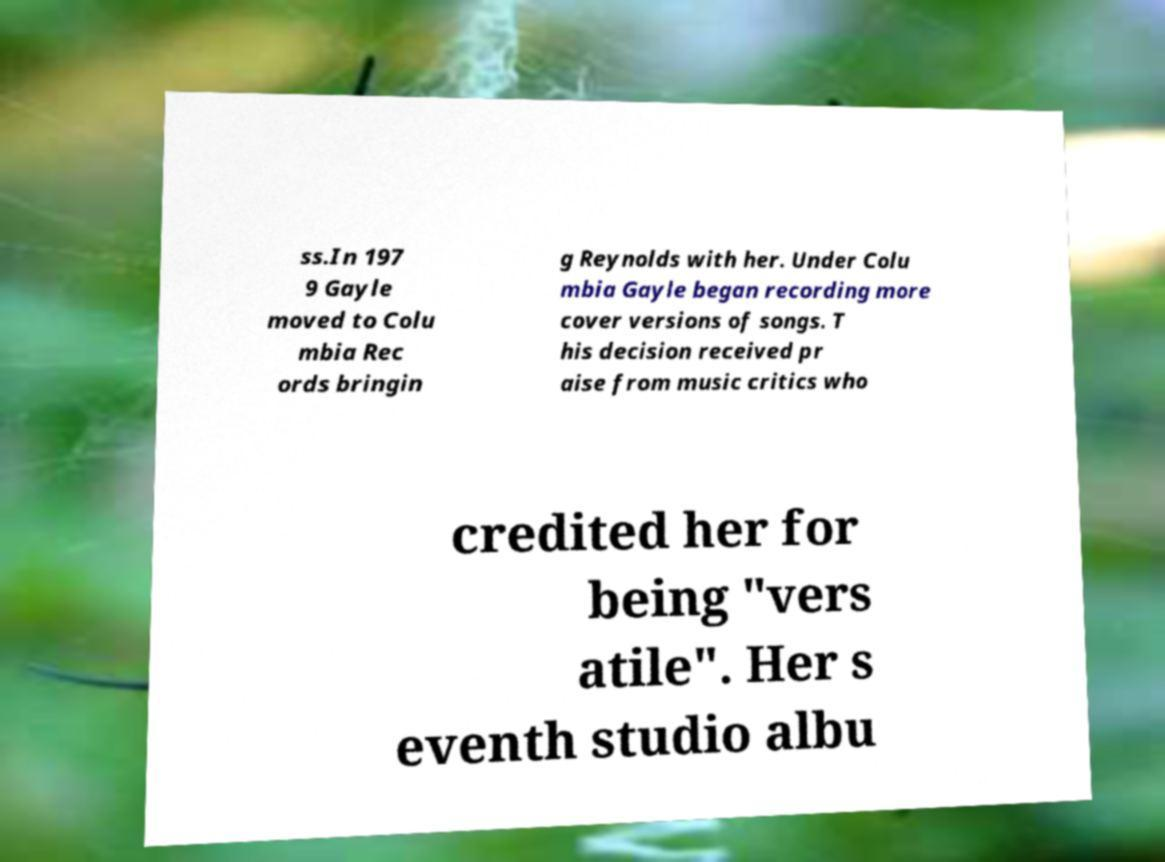Could you extract and type out the text from this image? ss.In 197 9 Gayle moved to Colu mbia Rec ords bringin g Reynolds with her. Under Colu mbia Gayle began recording more cover versions of songs. T his decision received pr aise from music critics who credited her for being "vers atile". Her s eventh studio albu 